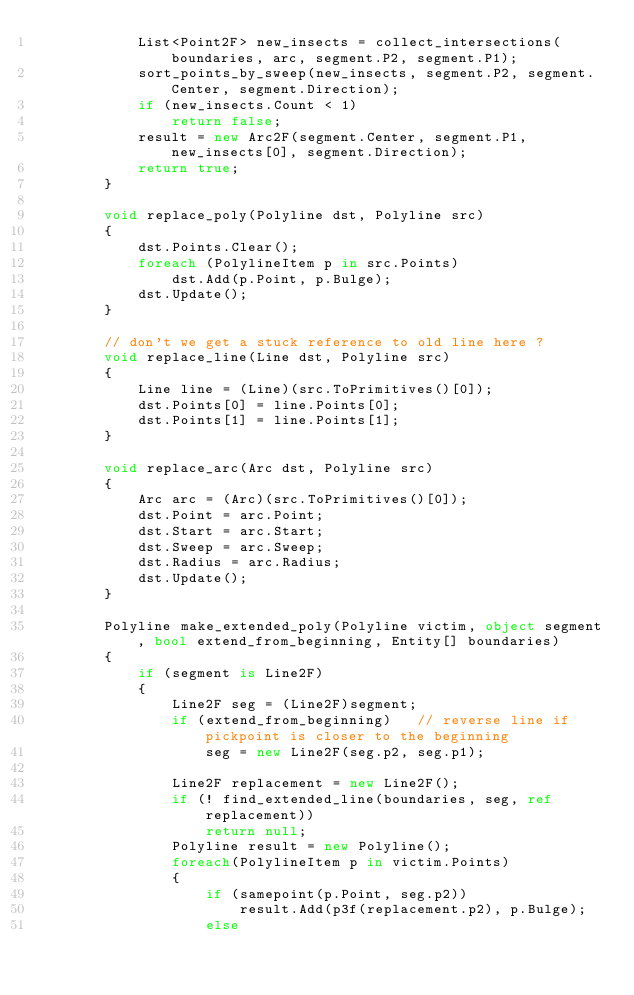<code> <loc_0><loc_0><loc_500><loc_500><_C#_>            List<Point2F> new_insects = collect_intersections(boundaries, arc, segment.P2, segment.P1);
            sort_points_by_sweep(new_insects, segment.P2, segment.Center, segment.Direction);
            if (new_insects.Count < 1)
                return false;
            result = new Arc2F(segment.Center, segment.P1, new_insects[0], segment.Direction);
            return true;
        }

        void replace_poly(Polyline dst, Polyline src)
        {
            dst.Points.Clear();
            foreach (PolylineItem p in src.Points)
                dst.Add(p.Point, p.Bulge);
            dst.Update();
        }

        // don't we get a stuck reference to old line here ?
        void replace_line(Line dst, Polyline src)
        {
            Line line = (Line)(src.ToPrimitives()[0]);
            dst.Points[0] = line.Points[0];
            dst.Points[1] = line.Points[1];
        }

        void replace_arc(Arc dst, Polyline src)
        {
            Arc arc = (Arc)(src.ToPrimitives()[0]);
            dst.Point = arc.Point;
            dst.Start = arc.Start;
            dst.Sweep = arc.Sweep;
            dst.Radius = arc.Radius;
            dst.Update();
        }

        Polyline make_extended_poly(Polyline victim, object segment, bool extend_from_beginning, Entity[] boundaries)
        {
            if (segment is Line2F)
            {
                Line2F seg = (Line2F)segment;
                if (extend_from_beginning)   // reverse line if pickpoint is closer to the beginning
                    seg = new Line2F(seg.p2, seg.p1);

                Line2F replacement = new Line2F();
                if (! find_extended_line(boundaries, seg, ref replacement))
                    return null;
                Polyline result = new Polyline();
                foreach(PolylineItem p in victim.Points)
                {
                    if (samepoint(p.Point, seg.p2))
                        result.Add(p3f(replacement.p2), p.Bulge);
                    else</code> 